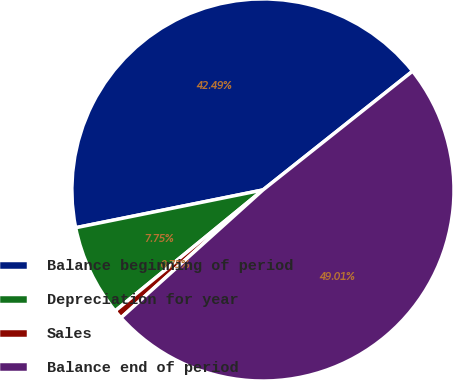Convert chart. <chart><loc_0><loc_0><loc_500><loc_500><pie_chart><fcel>Balance beginning of period<fcel>Depreciation for year<fcel>Sales<fcel>Balance end of period<nl><fcel>42.49%<fcel>7.75%<fcel>0.75%<fcel>49.01%<nl></chart> 